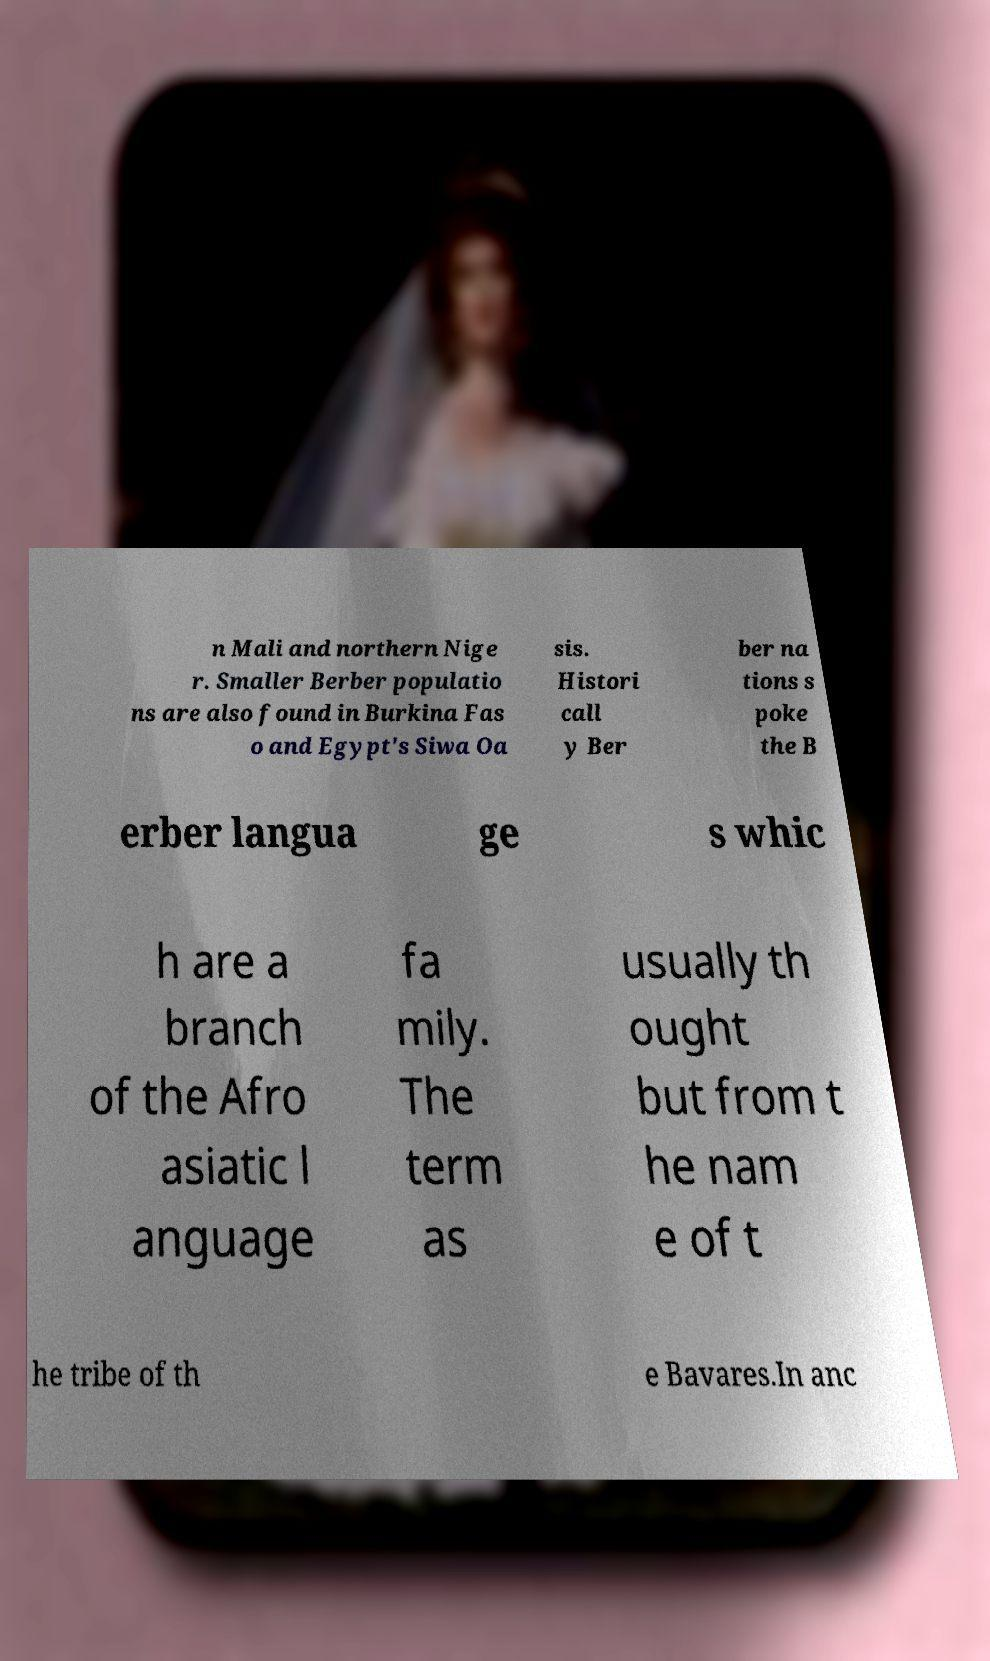There's text embedded in this image that I need extracted. Can you transcribe it verbatim? n Mali and northern Nige r. Smaller Berber populatio ns are also found in Burkina Fas o and Egypt's Siwa Oa sis. Histori call y Ber ber na tions s poke the B erber langua ge s whic h are a branch of the Afro asiatic l anguage fa mily. The term as usually th ought but from t he nam e of t he tribe of th e Bavares.In anc 